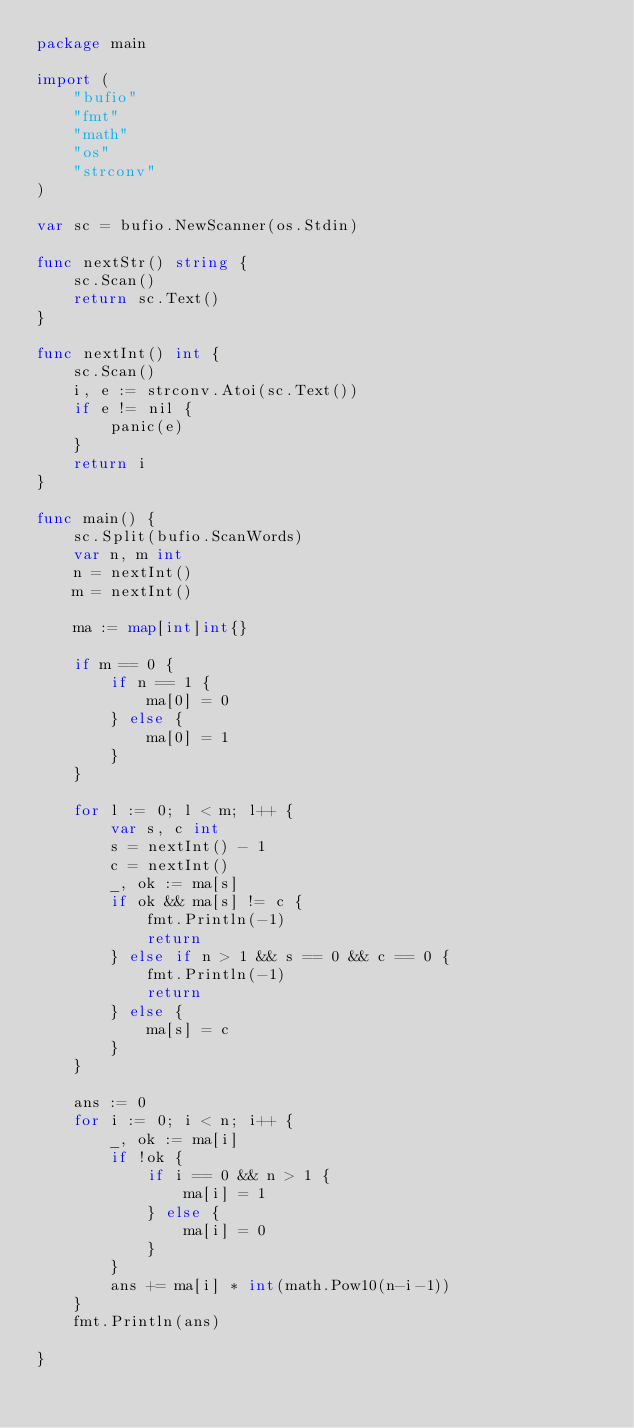<code> <loc_0><loc_0><loc_500><loc_500><_Go_>package main

import (
	"bufio"
	"fmt"
	"math"
	"os"
	"strconv"
)

var sc = bufio.NewScanner(os.Stdin)

func nextStr() string {
	sc.Scan()
	return sc.Text()
}

func nextInt() int {
	sc.Scan()
	i, e := strconv.Atoi(sc.Text())
	if e != nil {
		panic(e)
	}
	return i
}

func main() {
	sc.Split(bufio.ScanWords)
	var n, m int
	n = nextInt()
	m = nextInt()

	ma := map[int]int{}

	if m == 0 {
		if n == 1 {
			ma[0] = 0
		} else {
			ma[0] = 1
		}
	}

	for l := 0; l < m; l++ {
		var s, c int
		s = nextInt() - 1
		c = nextInt()
		_, ok := ma[s]
		if ok && ma[s] != c {
			fmt.Println(-1)
			return
		} else if n > 1 && s == 0 && c == 0 {
			fmt.Println(-1)
			return
		} else {
			ma[s] = c
		}
	}

	ans := 0
	for i := 0; i < n; i++ {
		_, ok := ma[i]
		if !ok {
			if i == 0 && n > 1 {
				ma[i] = 1
			} else {
				ma[i] = 0
			}
		}
		ans += ma[i] * int(math.Pow10(n-i-1))
	}
	fmt.Println(ans)

}
</code> 